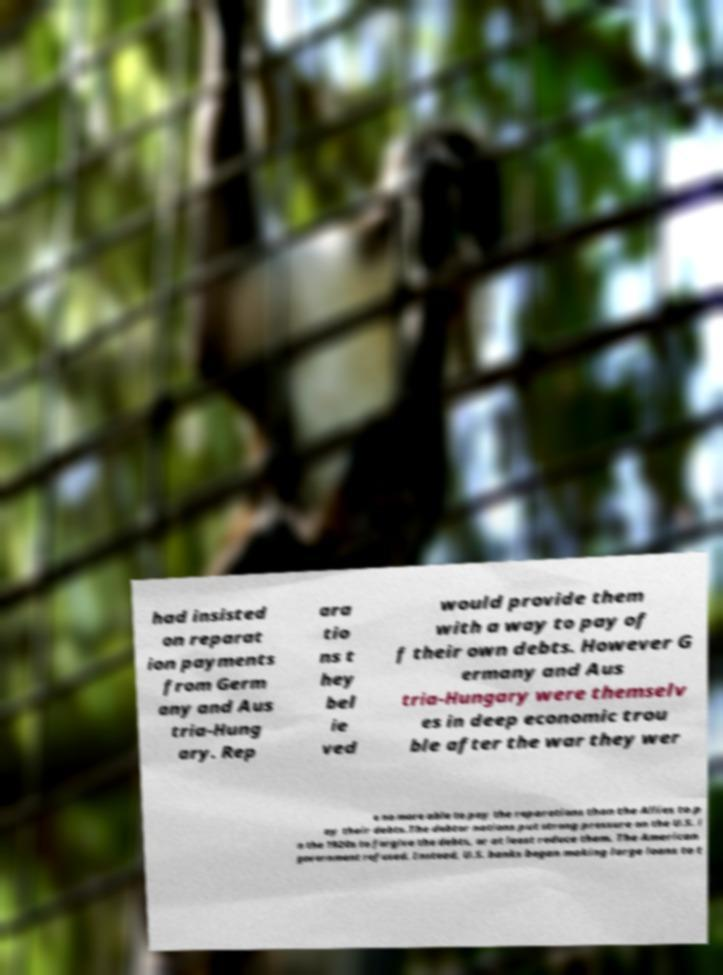Could you extract and type out the text from this image? had insisted on reparat ion payments from Germ any and Aus tria-Hung ary. Rep ara tio ns t hey bel ie ved would provide them with a way to pay of f their own debts. However G ermany and Aus tria-Hungary were themselv es in deep economic trou ble after the war they wer e no more able to pay the reparations than the Allies to p ay their debts.The debtor nations put strong pressure on the U.S. i n the 1920s to forgive the debts, or at least reduce them. The American government refused. Instead, U.S. banks began making large loans to t 